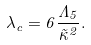Convert formula to latex. <formula><loc_0><loc_0><loc_500><loc_500>\lambda _ { c } = 6 \frac { \Lambda _ { 5 } } { \tilde { \kappa } ^ { 2 } } .</formula> 